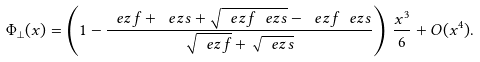Convert formula to latex. <formula><loc_0><loc_0><loc_500><loc_500>\Phi _ { \bot } ( x ) = \left ( 1 - \frac { \ e z f + \ e z s + \sqrt { \ e z f \ e z s } - \ e z f \ e z s } { \sqrt { \ e z f } + \sqrt { \ e z s } } \right ) \, \frac { x ^ { 3 } } { 6 } + O ( x ^ { 4 } ) .</formula> 